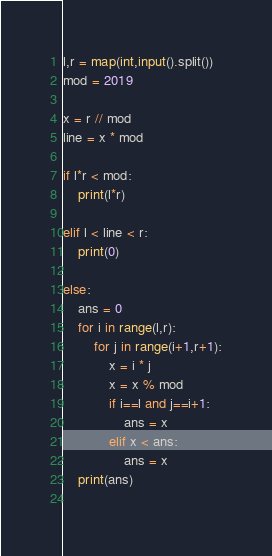<code> <loc_0><loc_0><loc_500><loc_500><_Python_>l,r = map(int,input().split())
mod = 2019

x = r // mod
line = x * mod

if l*r < mod:
    print(l*r)

elif l < line < r:
    print(0)

else:
    ans = 0
    for i in range(l,r):
        for j in range(i+1,r+1):
            x = i * j
            x = x % mod
            if i==l and j==i+1:
                ans = x
            elif x < ans:
                ans = x
    print(ans)
            </code> 